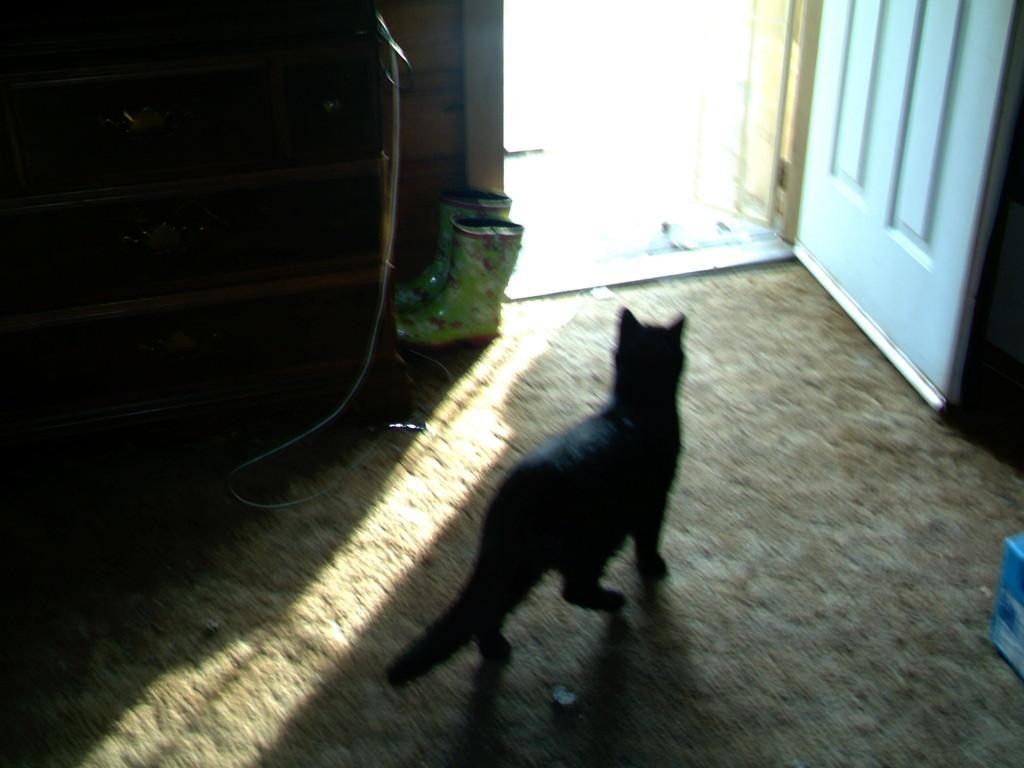In one or two sentences, can you explain what this image depicts? This looks like a black cat. These are the shoes. I can see the door, which is white in color. This looks like a pipe. 